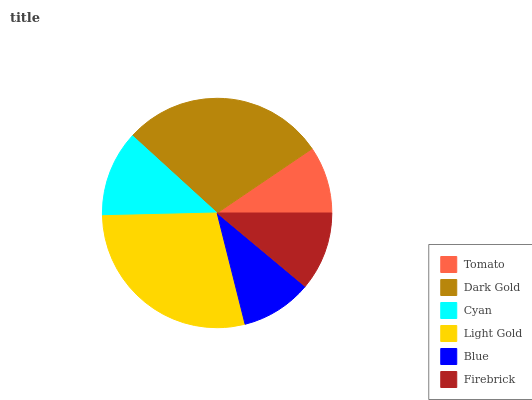Is Tomato the minimum?
Answer yes or no. Yes. Is Dark Gold the maximum?
Answer yes or no. Yes. Is Cyan the minimum?
Answer yes or no. No. Is Cyan the maximum?
Answer yes or no. No. Is Dark Gold greater than Cyan?
Answer yes or no. Yes. Is Cyan less than Dark Gold?
Answer yes or no. Yes. Is Cyan greater than Dark Gold?
Answer yes or no. No. Is Dark Gold less than Cyan?
Answer yes or no. No. Is Cyan the high median?
Answer yes or no. Yes. Is Firebrick the low median?
Answer yes or no. Yes. Is Dark Gold the high median?
Answer yes or no. No. Is Cyan the low median?
Answer yes or no. No. 